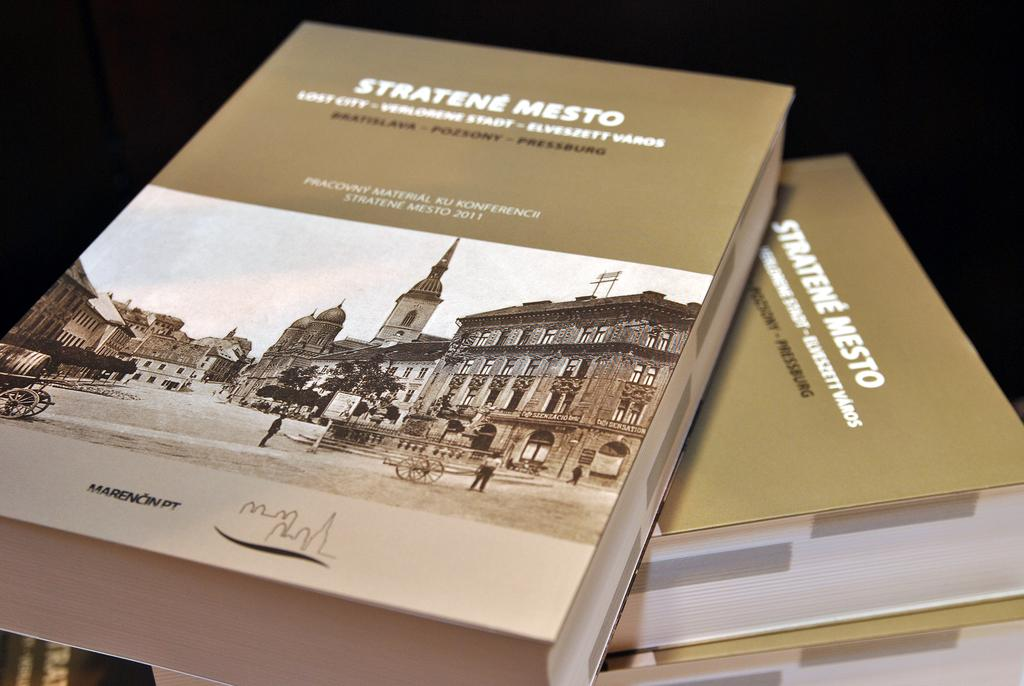Provide a one-sentence caption for the provided image. Stratene Mesto books that show a city and some people. 